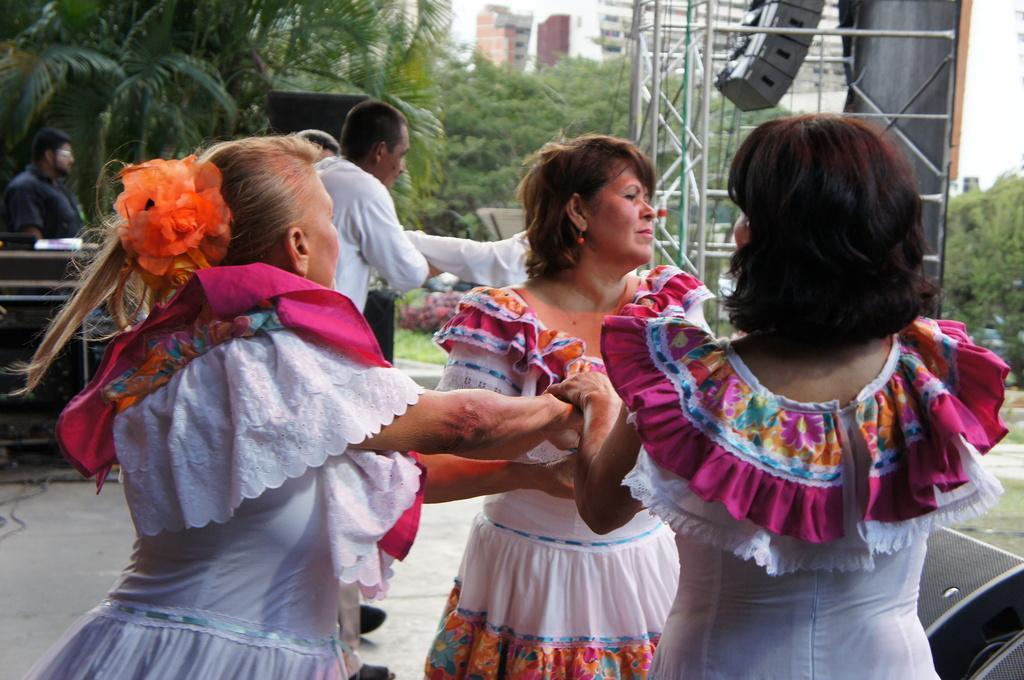Could you give a brief overview of what you see in this image? In this we can see there are three women standing in the foreground, and there are some other people standing at the back, and there are some trees. 